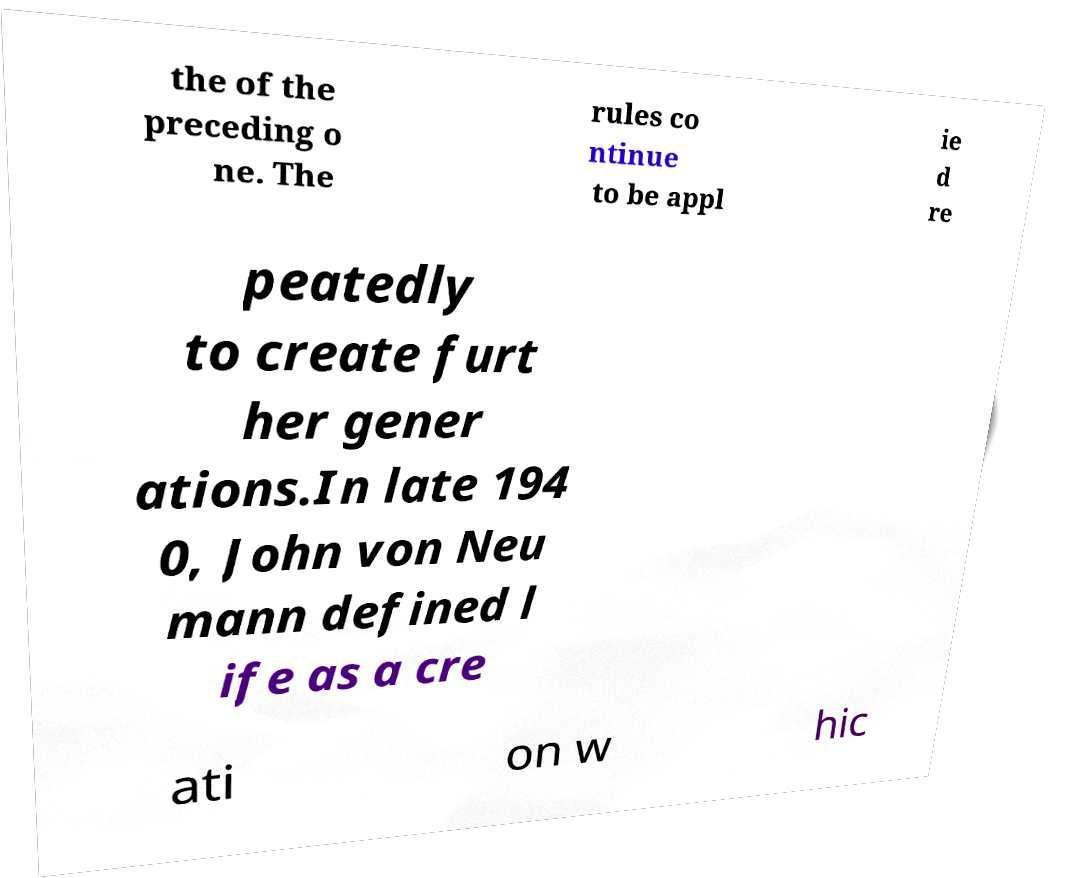Could you assist in decoding the text presented in this image and type it out clearly? the of the preceding o ne. The rules co ntinue to be appl ie d re peatedly to create furt her gener ations.In late 194 0, John von Neu mann defined l ife as a cre ati on w hic 